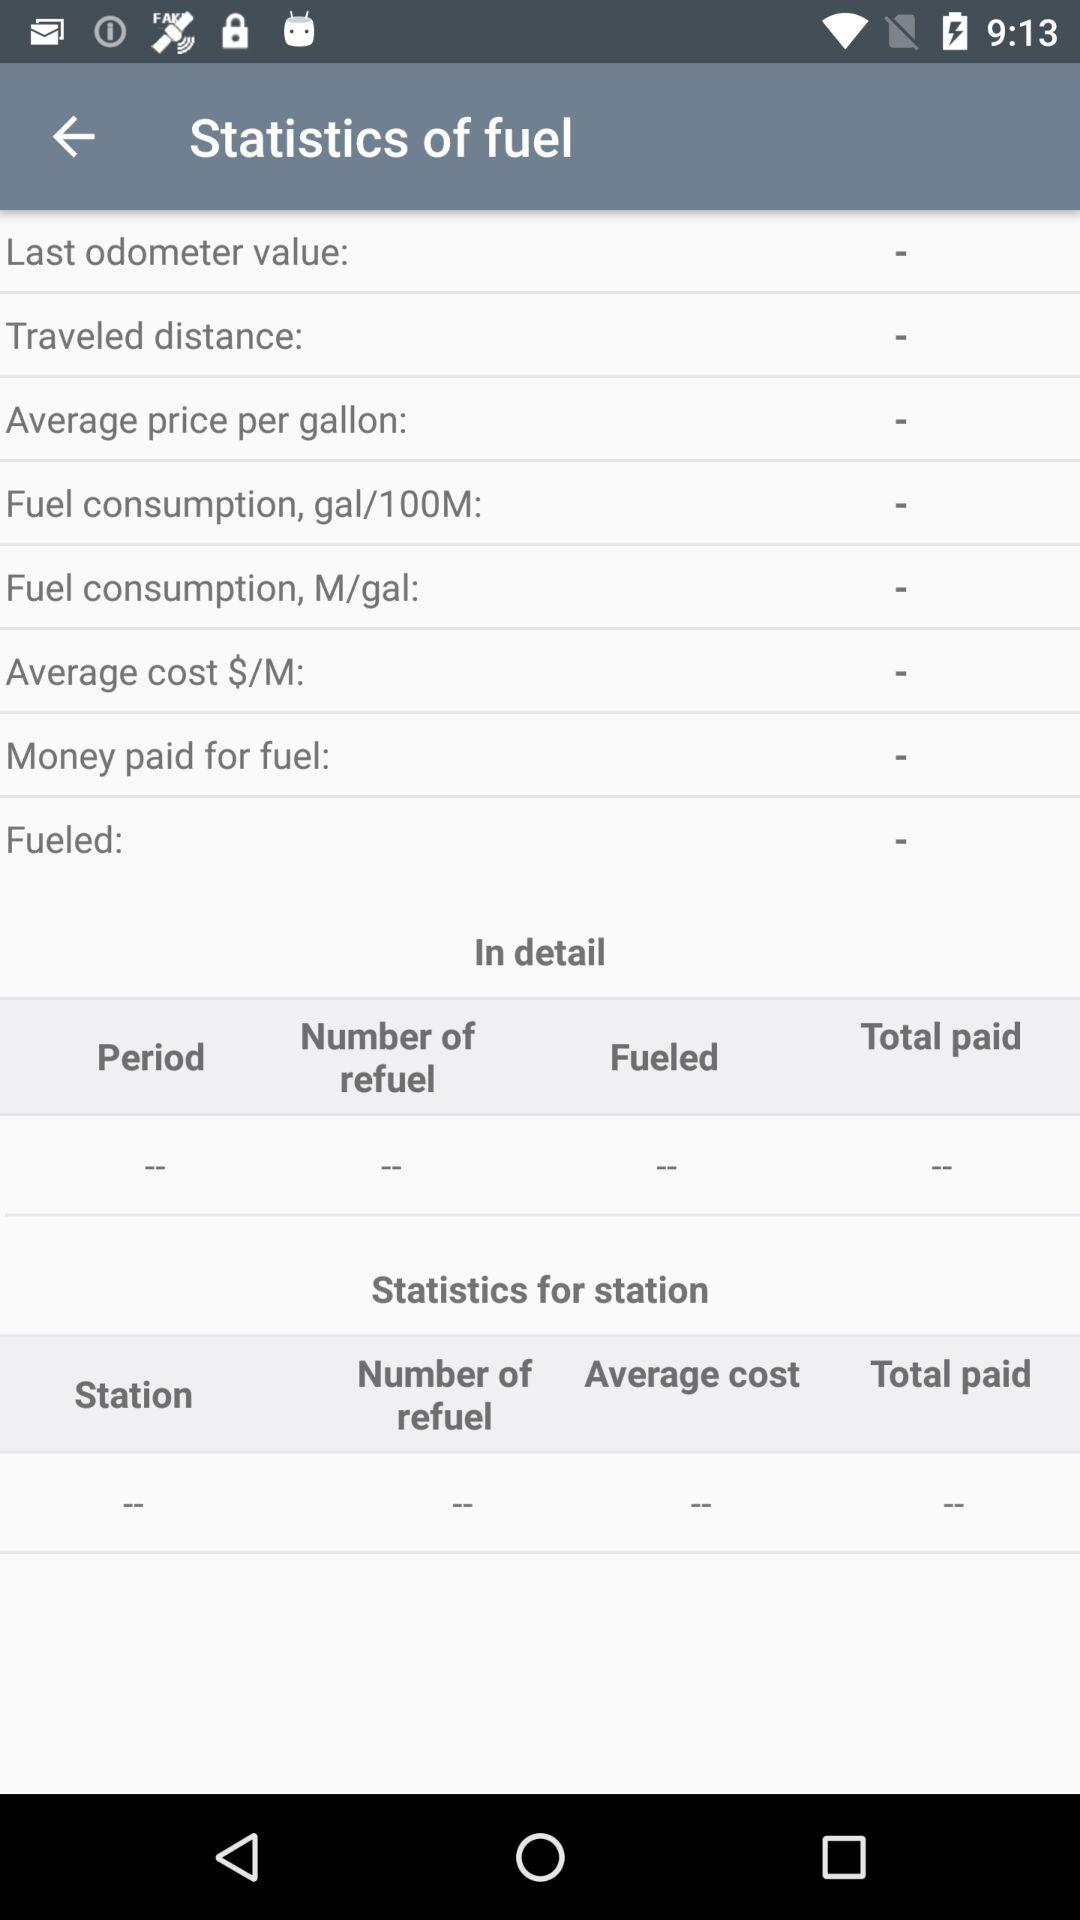What's selected currency for cumulating the Average Cost?
When the provided information is insufficient, respond with <no answer>. <no answer> 